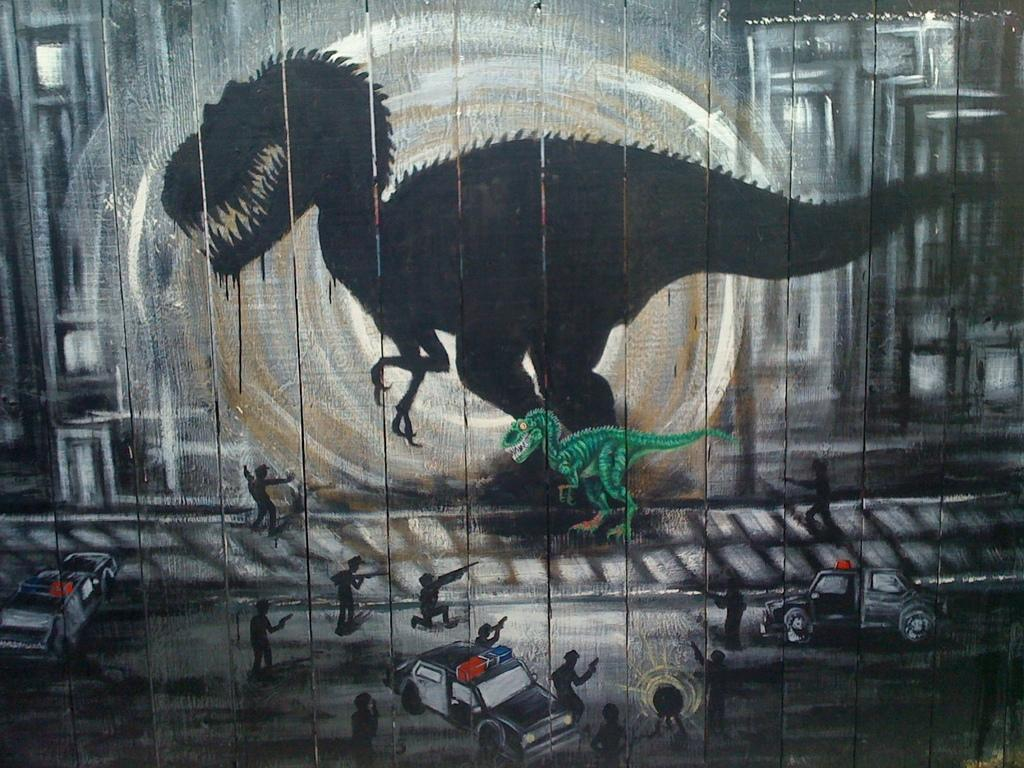What is the main subject of the painting? There is a dinosaur in the painting. Can you describe any other features of the dinosaur? There is a reflection of the dinosaur in the painting. What else can be seen in the painting besides the dinosaur? There are people with guns and vehicles in the painting. What type of verse can be heard recited by the dinosaur in the painting? There is no verse being recited by the dinosaur in the painting, as it is a static image and not a performance. 